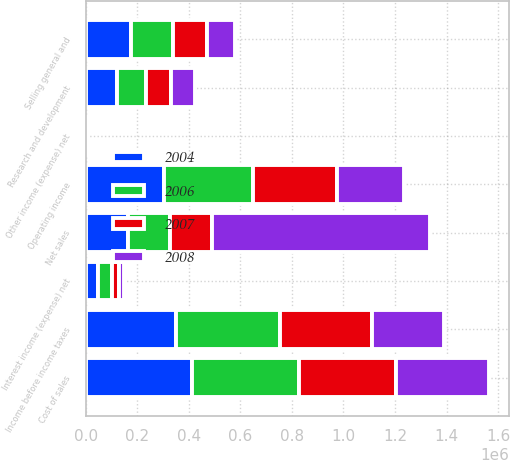Convert chart. <chart><loc_0><loc_0><loc_500><loc_500><stacked_bar_chart><ecel><fcel>Net sales<fcel>Cost of sales<fcel>Research and development<fcel>Selling general and<fcel>Operating income<fcel>Interest income (expense) net<fcel>Other income (expense) net<fcel>Income before income taxes<nl><fcel>2004<fcel>163247<fcel>410799<fcel>120864<fcel>175646<fcel>301665<fcel>46885<fcel>2435<fcel>350985<nl><fcel>2006<fcel>163247<fcel>414915<fcel>113698<fcel>163247<fcel>347811<fcel>52967<fcel>312<fcel>401090<nl><fcel>2007<fcel>163247<fcel>377016<fcel>94926<fcel>129587<fcel>326364<fcel>30786<fcel>2035<fcel>359185<nl><fcel>2008<fcel>846936<fcel>362961<fcel>93040<fcel>111188<fcel>258647<fcel>16864<fcel>1757<fcel>277268<nl></chart> 